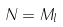<formula> <loc_0><loc_0><loc_500><loc_500>N = M _ { l }</formula> 